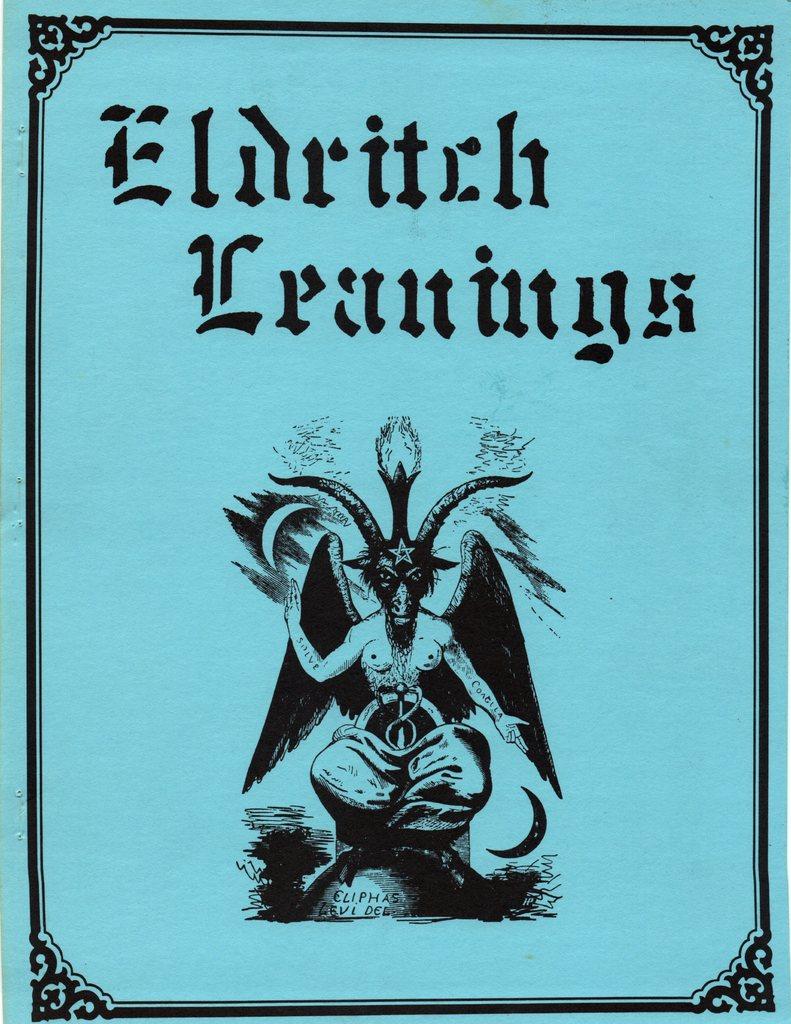What is the title on this page?
Your response must be concise. Eldritch leanings. What color is the text on this page?
Give a very brief answer. Black. 